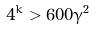<formula> <loc_0><loc_0><loc_500><loc_500>4 ^ { k } > 6 0 0 \gamma ^ { 2 }</formula> 